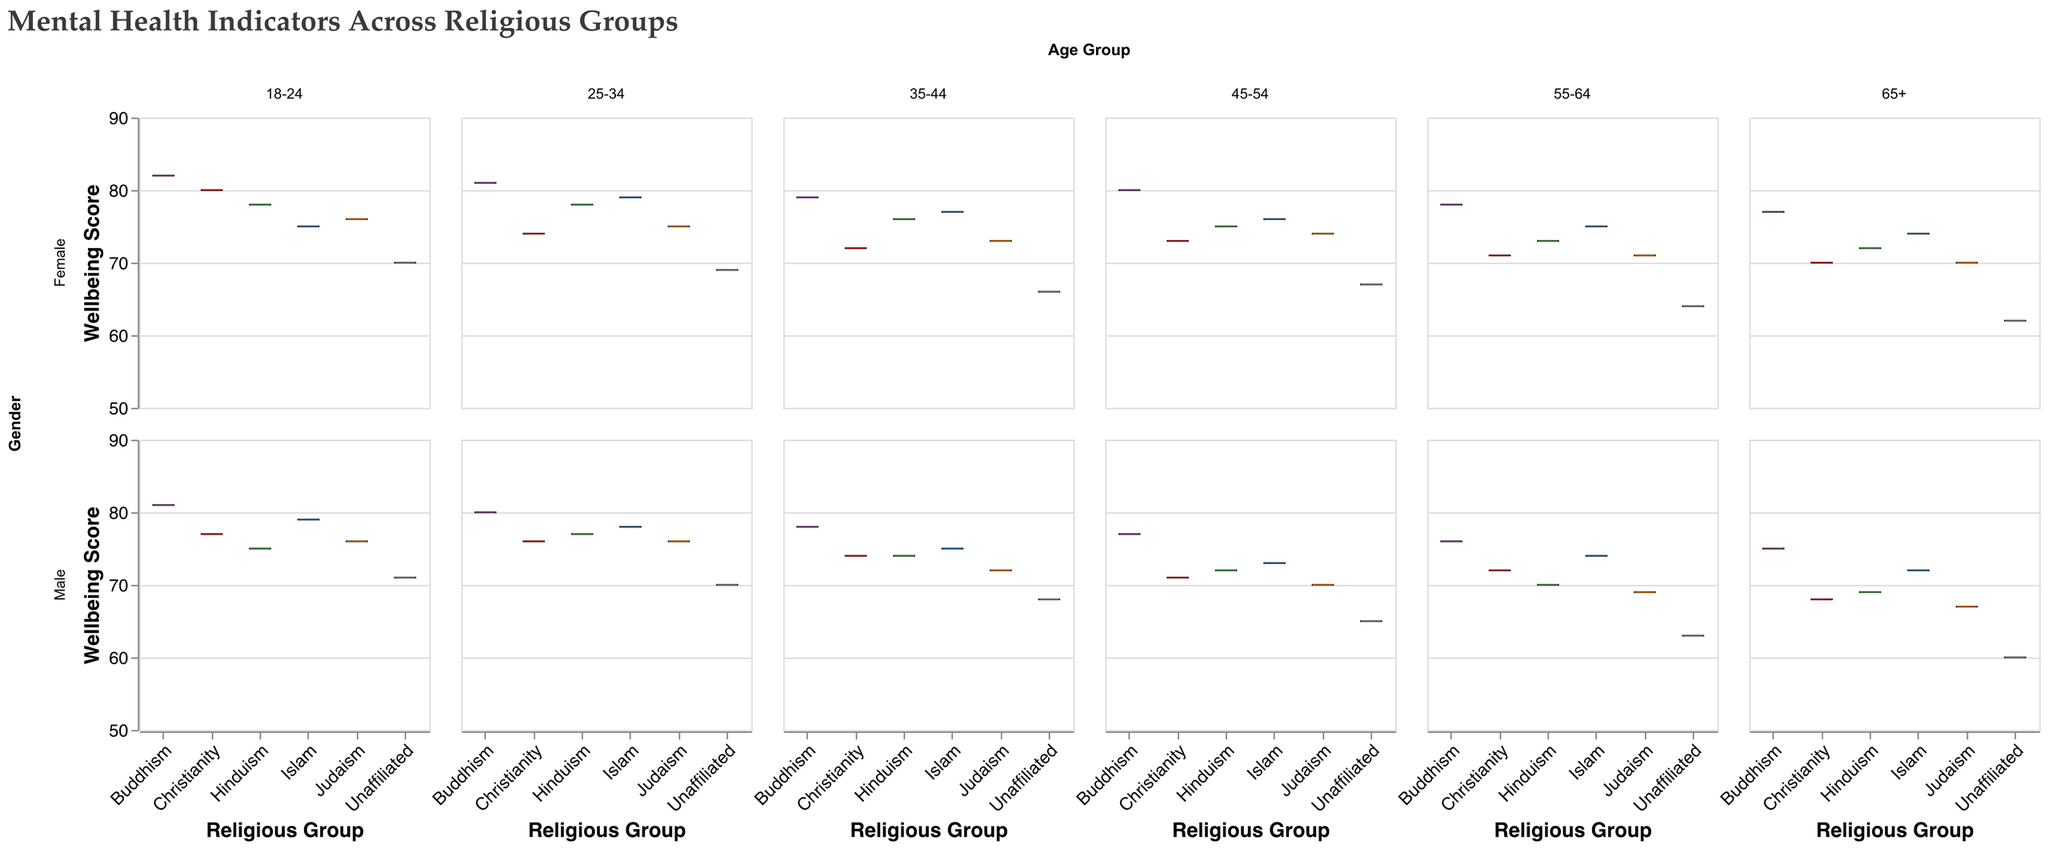Which age group has the highest median wellbeing score for females in Buddhism? By looking at the boxes for females who identify with Buddhism across different age groups, the 45-54 age group has the highest median wellbeing score as indicated by the line inside the box plot.
Answer: 45-54 What is the general trend in wellbeing scores for males unaffiliated across different age groups? Observing the plot for males under the unaffiliated category, the wellbeing score tends to decrease as the age group increases.
Answer: Decreasing Which religious group has the lowest median wellbeing score for the 18-24 age group, regardless of gender? By looking at the median lines inside the boxes for the 18-24 age group across all religions, the unaffiliated group has the lowest median wellbeing score.
Answer: Unaffiliated For the 35-44 age group, which gender shows higher median wellbeing scores in Judaism? Comparing the medians in the Judaism category, females have a higher median wellbeing score than males in the 35-44 age group.
Answer: Females How does the median wellbeing score for Islam in the 25-34 male group compare with the 25-34 female group? The median wellbeing score for males in the 25-34 age group of Islam is lower than that for females.
Answer: Lower Which religious group has the most consistent wellbeing scores across all age groups for males? By checking the length of the interquartile range (the box) across all age groups for males, Buddhism appears to have the most consistent (smallest variation) wellbeing scores.
Answer: Buddhism What's the difference in the median wellbeing scores between males and females in Christianity for the 65+ age group? The median for males in Christianity of the 65+ age group is 68 and for females is 70, leading to a difference of 70 - 68.
Answer: 2 Among females in the 55-64 age group, which religious group shows the widest range in wellbeing scores? By measuring the length of the whiskers (minimum and maximum) for each religious group under the 55-64 female category, Judaism has the widest range.
Answer: Judaism Are there any age groups where males and females show no difference in the median wellbeing scores for Hinduism? By comparing the median lines for both genders across each age group within Hinduism, the 45-54 age group shows no difference.
Answer: 45-54 